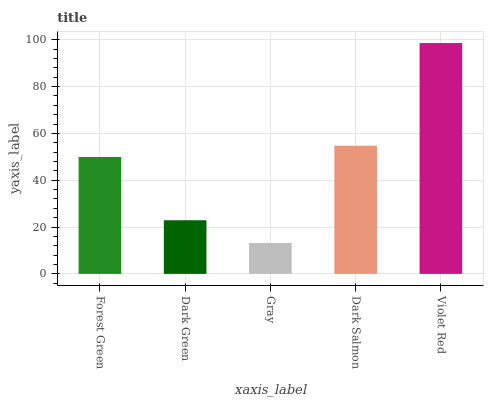Is Dark Green the minimum?
Answer yes or no. No. Is Dark Green the maximum?
Answer yes or no. No. Is Forest Green greater than Dark Green?
Answer yes or no. Yes. Is Dark Green less than Forest Green?
Answer yes or no. Yes. Is Dark Green greater than Forest Green?
Answer yes or no. No. Is Forest Green less than Dark Green?
Answer yes or no. No. Is Forest Green the high median?
Answer yes or no. Yes. Is Forest Green the low median?
Answer yes or no. Yes. Is Dark Salmon the high median?
Answer yes or no. No. Is Gray the low median?
Answer yes or no. No. 